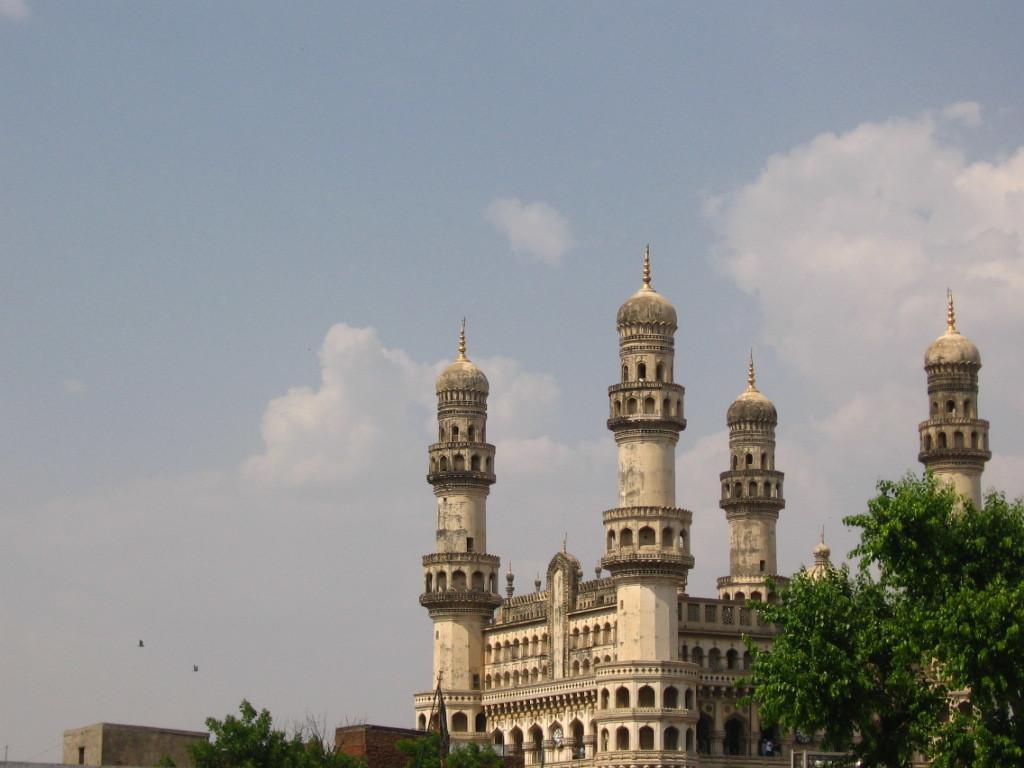Describe this image in one or two sentences. In this image I can see a monument on the right side of the image and in the right bottom corner I can see a tree and at the top of the image I can see the sky.  